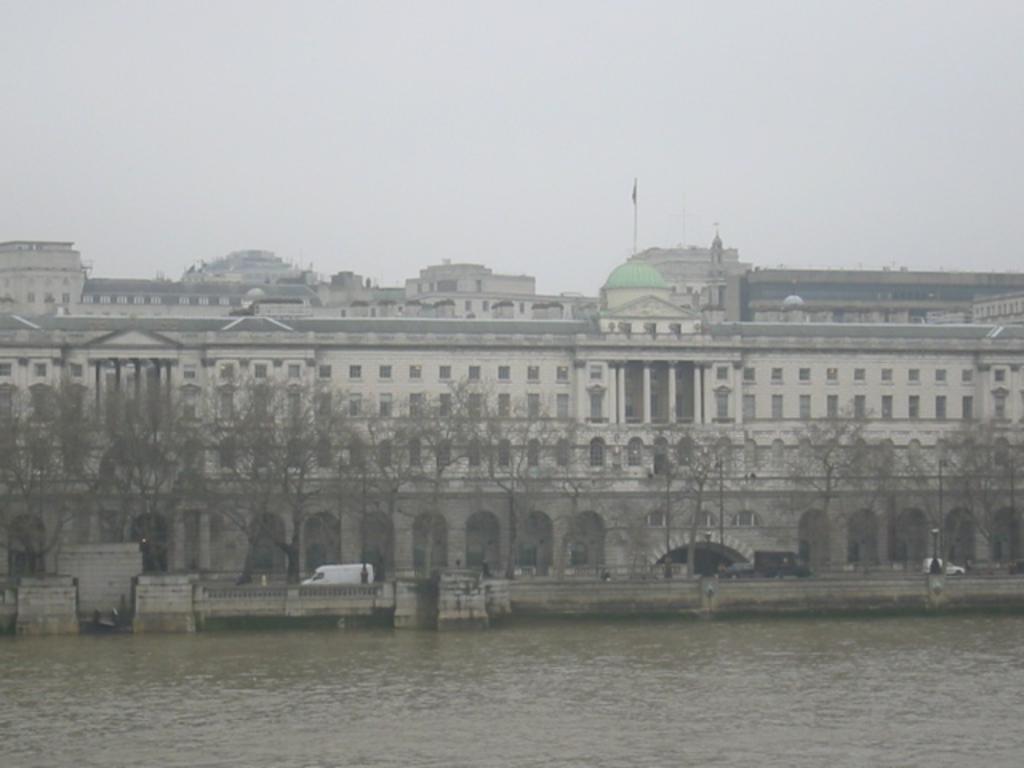Please provide a concise description of this image. In this picture we can see building. Here we can see a flag which is on the dome. On the bottom we can see water. Here we can see a white color car which is near to the fencing. Here we can see many trees in front of the building. On the top we can see sky and clouds. On the right we can see a pole. 